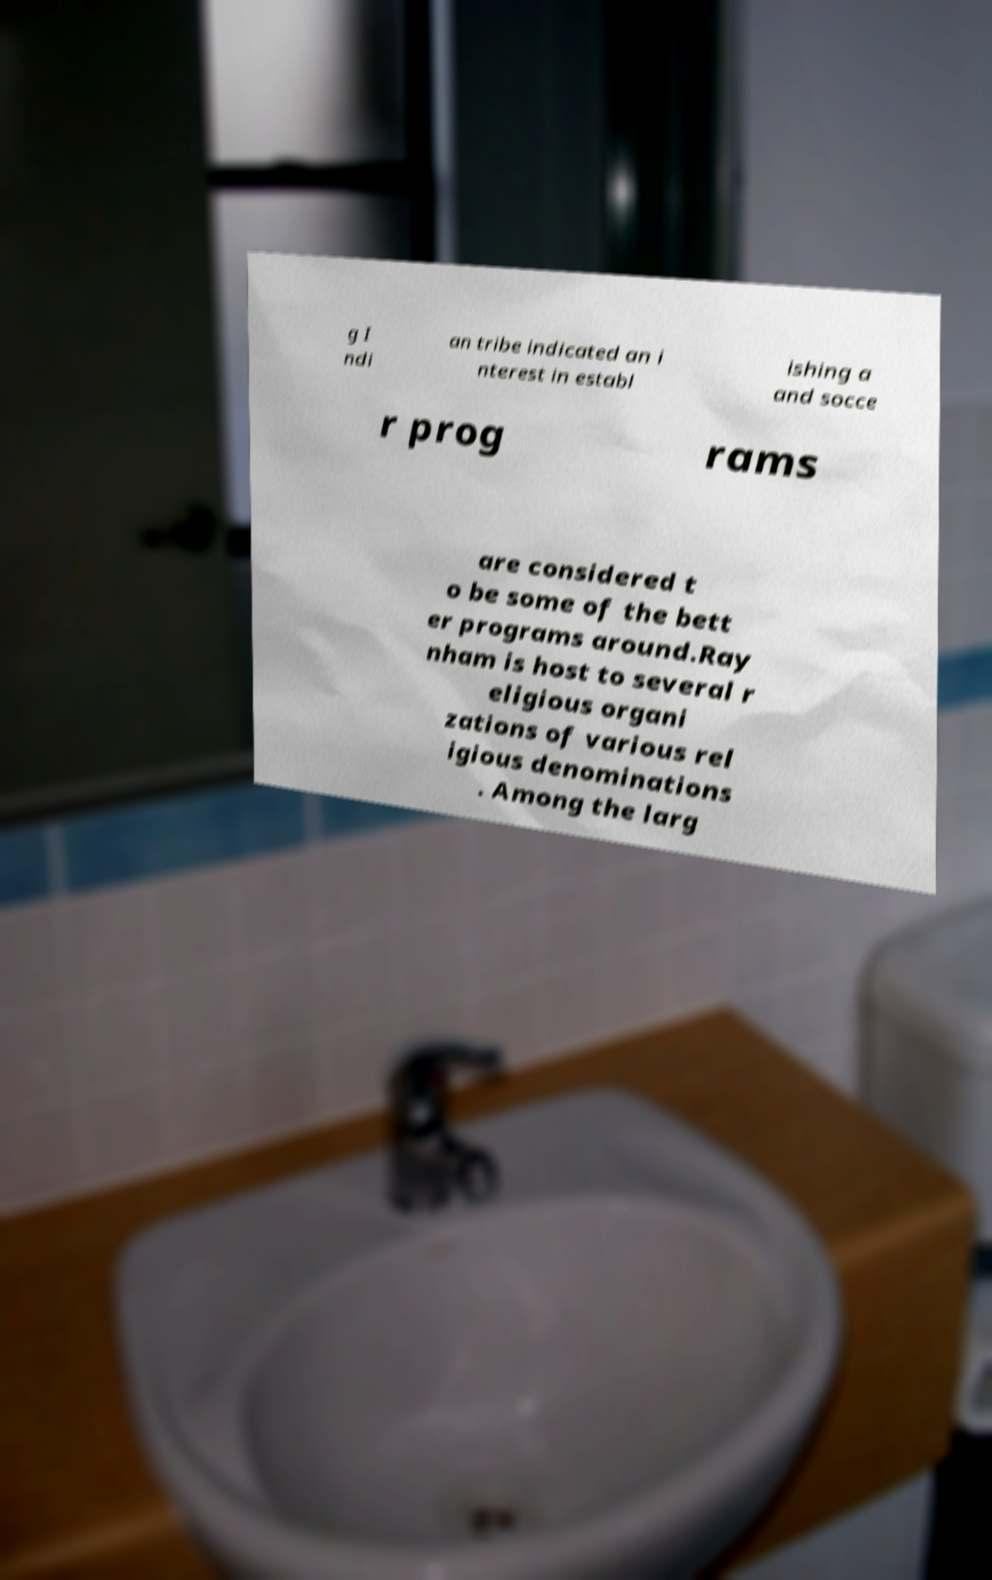Please identify and transcribe the text found in this image. g I ndi an tribe indicated an i nterest in establ ishing a and socce r prog rams are considered t o be some of the bett er programs around.Ray nham is host to several r eligious organi zations of various rel igious denominations . Among the larg 